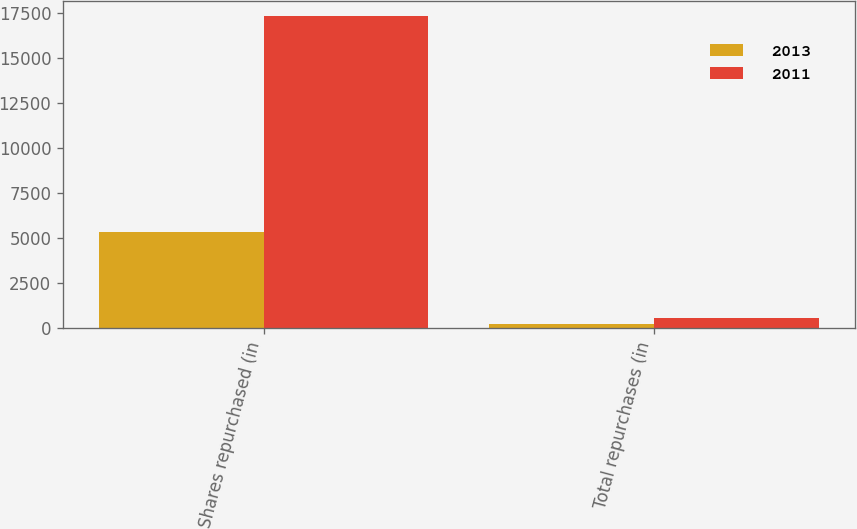Convert chart to OTSL. <chart><loc_0><loc_0><loc_500><loc_500><stacked_bar_chart><ecel><fcel>Shares repurchased (in<fcel>Total repurchases (in<nl><fcel>2013<fcel>5368<fcel>239<nl><fcel>2011<fcel>17338<fcel>575<nl></chart> 